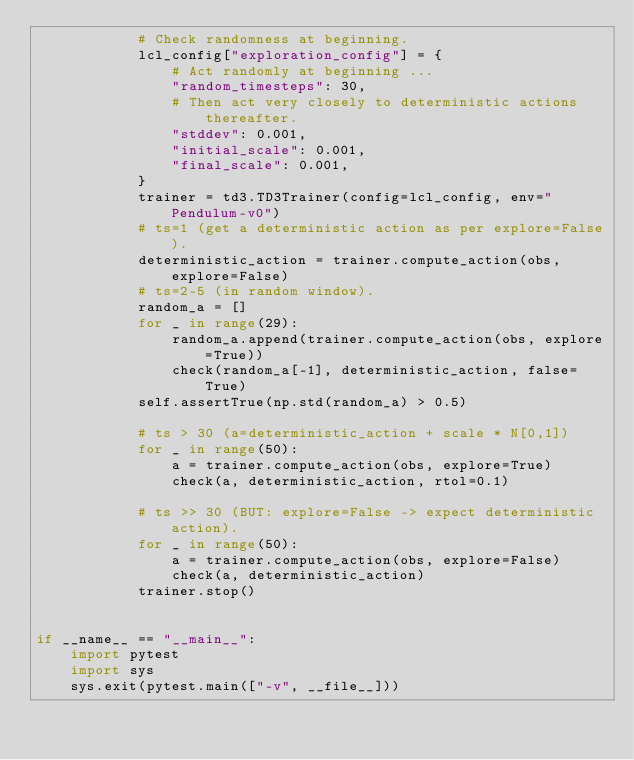<code> <loc_0><loc_0><loc_500><loc_500><_Python_>            # Check randomness at beginning.
            lcl_config["exploration_config"] = {
                # Act randomly at beginning ...
                "random_timesteps": 30,
                # Then act very closely to deterministic actions thereafter.
                "stddev": 0.001,
                "initial_scale": 0.001,
                "final_scale": 0.001,
            }
            trainer = td3.TD3Trainer(config=lcl_config, env="Pendulum-v0")
            # ts=1 (get a deterministic action as per explore=False).
            deterministic_action = trainer.compute_action(obs, explore=False)
            # ts=2-5 (in random window).
            random_a = []
            for _ in range(29):
                random_a.append(trainer.compute_action(obs, explore=True))
                check(random_a[-1], deterministic_action, false=True)
            self.assertTrue(np.std(random_a) > 0.5)

            # ts > 30 (a=deterministic_action + scale * N[0,1])
            for _ in range(50):
                a = trainer.compute_action(obs, explore=True)
                check(a, deterministic_action, rtol=0.1)

            # ts >> 30 (BUT: explore=False -> expect deterministic action).
            for _ in range(50):
                a = trainer.compute_action(obs, explore=False)
                check(a, deterministic_action)
            trainer.stop()


if __name__ == "__main__":
    import pytest
    import sys
    sys.exit(pytest.main(["-v", __file__]))
</code> 